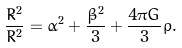<formula> <loc_0><loc_0><loc_500><loc_500>\frac { \dot { R } ^ { 2 } } { R ^ { 2 } } = \dot { \alpha } ^ { 2 } + \frac { \dot { \beta } ^ { 2 } } { 3 } + \frac { 4 \pi G } { 3 } \rho .</formula> 